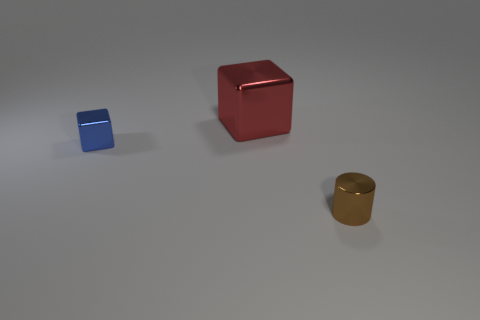Add 3 big red cubes. How many objects exist? 6 Subtract all cylinders. How many objects are left? 2 Subtract all large metallic things. Subtract all red objects. How many objects are left? 1 Add 1 large objects. How many large objects are left? 2 Add 2 tiny blue things. How many tiny blue things exist? 3 Subtract 0 brown balls. How many objects are left? 3 